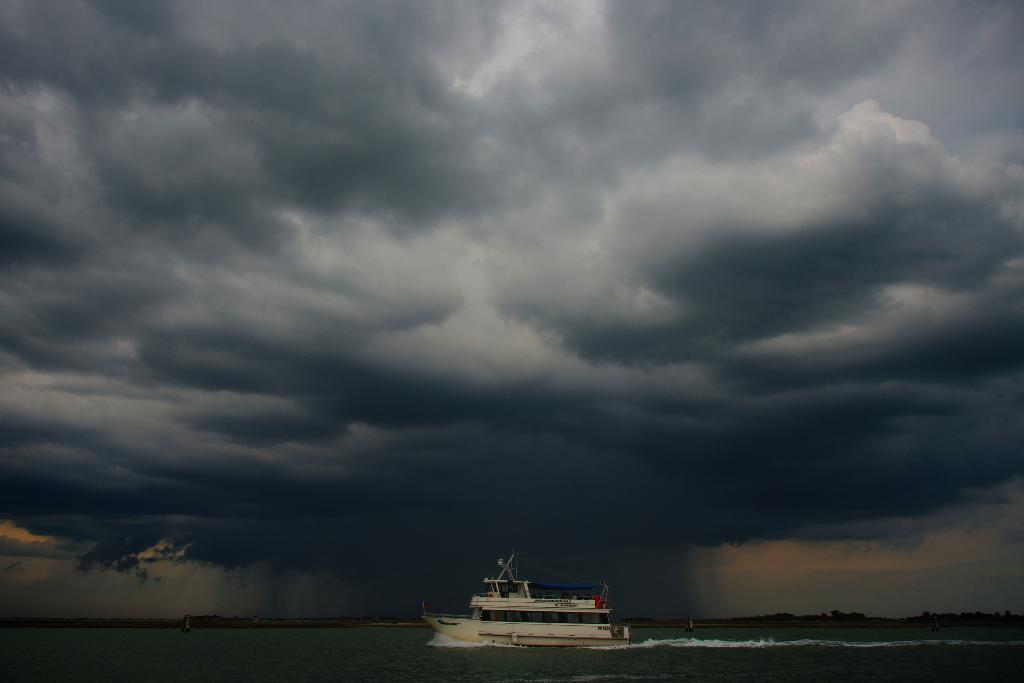What is the color of the boat in the image? The boat in the image is white. Where is the boat located? The boat is in the water. What can be seen in the sky in the image? The sky is visible in the image, and clouds are present. How many boys are walking on the sidewalk near the boat in the image? There are no boys or sidewalks present in the image. 